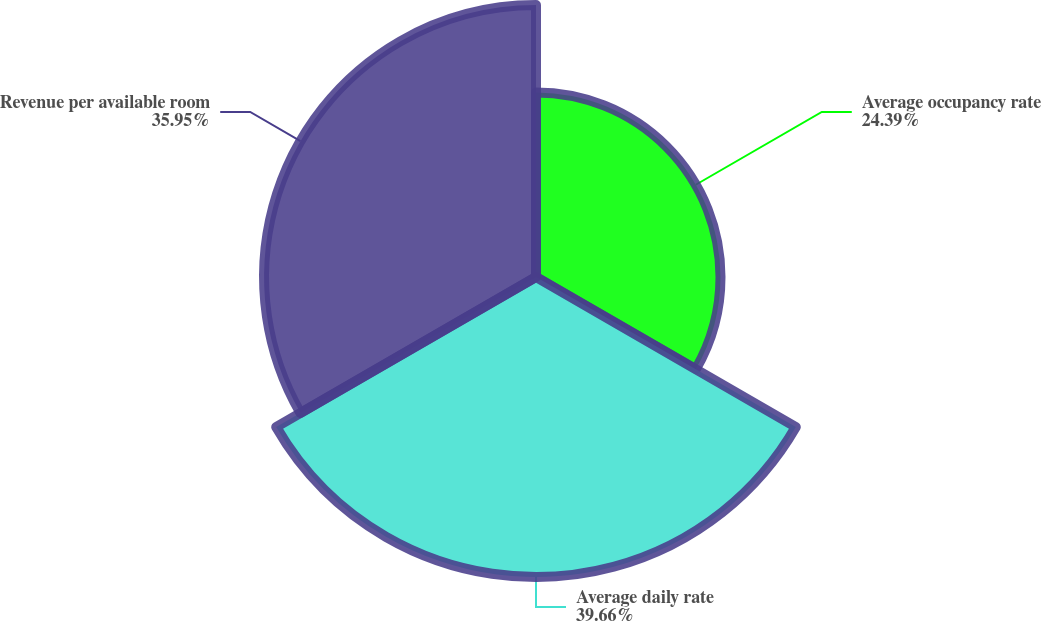Convert chart. <chart><loc_0><loc_0><loc_500><loc_500><pie_chart><fcel>Average occupancy rate<fcel>Average daily rate<fcel>Revenue per available room<nl><fcel>24.39%<fcel>39.66%<fcel>35.95%<nl></chart> 